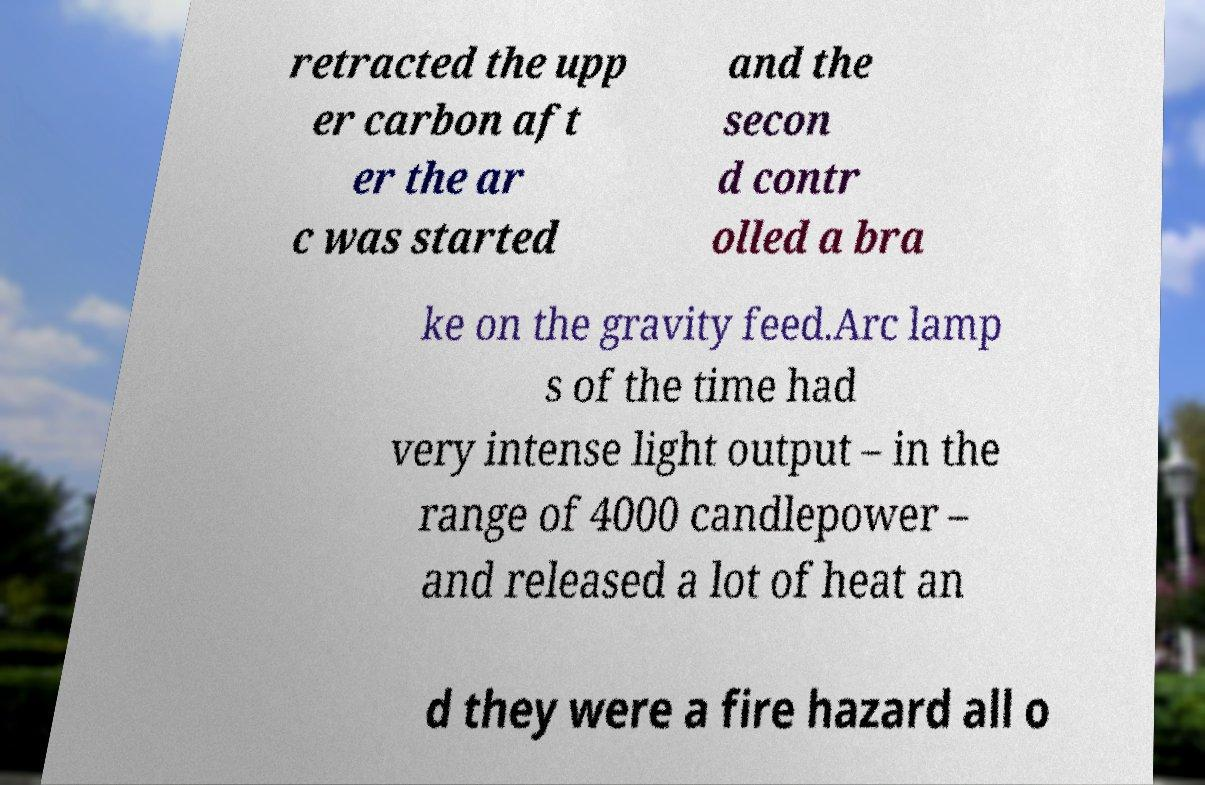Can you accurately transcribe the text from the provided image for me? retracted the upp er carbon aft er the ar c was started and the secon d contr olled a bra ke on the gravity feed.Arc lamp s of the time had very intense light output – in the range of 4000 candlepower – and released a lot of heat an d they were a fire hazard all o 